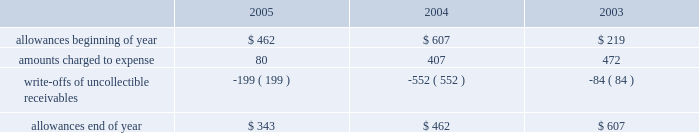Goodwill is reviewed annually during the fourth quarter for impairment .
In addition , the company performs an impairment analysis of other intangible assets based on the occurrence of other factors .
Such factors include , but are not limited to , signifi- cant changes in membership , state funding , medical contracts and provider networks and contracts .
An impairment loss is rec- ognized if the carrying value of intangible assets exceeds the implied fair value .
The company did not recognize any impair- ment losses for the periods presented .
Medical claims liabilities medical services costs include claims paid , claims reported but not yet paid ( inventory ) , estimates for claims incurred but not yet received ( ibnr ) and estimates for the costs necessary to process unpaid claims .
The estimates of medical claims liabilities are developed using standard actuarial methods based upon historical data for payment patterns , cost trends , product mix , seasonality , utiliza- tion of healthcare services and other relevant factors including product changes .
These estimates are continually reviewed and adjustments , if necessary , are reflected in the period known .
Management did not change actuarial methods during the years presented .
Management believes the amount of medical claims payable is reasonable and adequate to cover the company 2019s liabil- ity for unpaid claims as of december 31 , 2005 ; however , actual claim payments may differ from established estimates .
Revenue recognition the majority of the company 2019s medicaid managed care premi- um revenue is received monthly based on fixed rates per member as determined by state contracts .
Some contracts allow for addi- tional premium related to certain supplemental services provided such as maternity deliveries .
Revenue is recognized as earned over the covered period of services .
Revenues are recorded based on membership and eligibility data provided by the states , which may be adjusted by the states for updates to this membership and eligibility data .
These adjustments are immaterial in relation to total revenue recorded and are reflected in the period known .
Premiums collected in advance are recorded as unearned revenue .
The specialty services segment generates revenue under con- tracts with state and local government entities , our health plans and third-party customers .
Revenues for services are recognized when the services are provided or as ratably earned over the cov- ered period of services .
For performance-based contracts , the company does not recognize revenue subject to refund until data is sufficient to measure performance .
Such amounts are recorded as unearned revenue .
Revenues due to the company are recorded as premium and related receivables and recorded net of an allowance for uncol- lectible accounts based on historical trends and management 2019s judgment on the collectibility of these accounts .
Activity in the allowance for uncollectible accounts for the years ended december 31 is summarized below: .
Significant customers centene receives the majority of its revenues under contracts or subcontracts with state medicaid managed care programs .
The contracts , which expire on various dates between june 30 , 2006 and august 31 , 2008 , are expected to be renewed .
Contracts with the states of indiana , kansas , texas and wisconsin each accounted for 18% ( 18 % ) , 12% ( 12 % ) , 22% ( 22 % ) and 23% ( 23 % ) , respectively , of the company 2019s revenues for the year ended december 31 , 2005 .
Reinsurance centene has purchased reinsurance from third parties to cover eligible healthcare services .
The current reinsurance program covers 90% ( 90 % ) of inpatient healthcare expenses in excess of annual deductibles of $ 300 per member , up to a lifetime maximum of $ 2000 .
Centene 2019s medicaid managed care subsidiaries are respon- sible for inpatient charges in excess of an average daily per diem .
Reinsurance recoveries were $ 4014 , $ 3730 , and $ 5345 , in 2005 , 2004 , and 2003 , respectively .
Reinsurance expenses were approximately $ 4105 , $ 6724 , and $ 6185 in 2005 , 2004 , and 2003 , respectively .
Reinsurance recoveries , net of expenses , are included in medical costs .
Other income ( expense ) other income ( expense ) consists principally of investment income and interest expense .
Investment income is derived from the company 2019s cash , cash equivalents , restricted deposits and investments .
Interest expense relates to borrowings under our credit facility , mortgage interest , interest on capital leases and credit facility fees .
Income taxes deferred tax assets and liabilities are recorded for the future tax consequences attributable to differences between the financial statement carrying amounts of existing assets and liabilities and their respective tax bases .
Deferred tax assets and liabilities are measured using enacted tax rates expected to apply to taxable income in the years in which those temporary differences are expected to be recovered or settled .
The effect on deferred tax assets and liabilities of a change in tax rates is recognized in income in the period that includes the enactment date of the tax rate change .
Valuation allowances are provided when it is considered more likely than not that deferred tax assets will not be realized .
In determining if a deductible temporary difference or net operating loss can be realized , the company considers future reversals of .
What was the percentage change in the allowance for uncollectible accounts from year end 2004 to 2005? 
Computations: ((343 - 462) / 462)
Answer: -0.25758. 